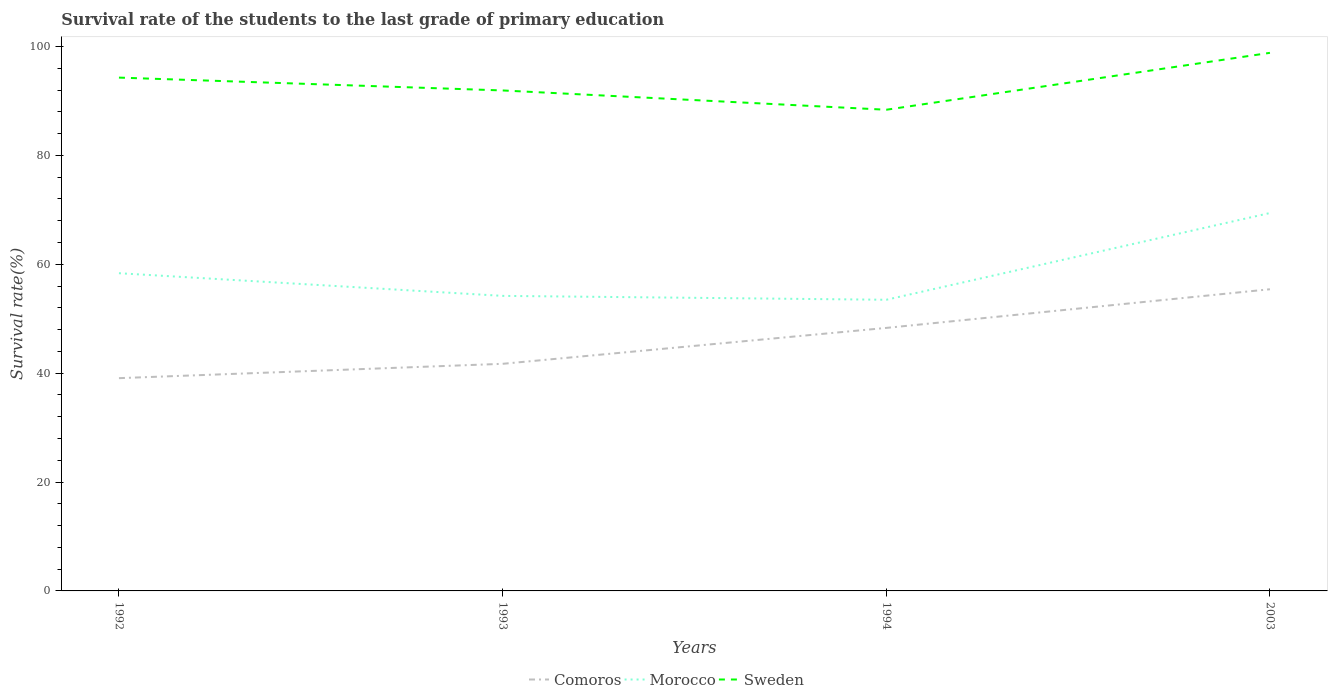How many different coloured lines are there?
Provide a succinct answer. 3. Across all years, what is the maximum survival rate of the students in Comoros?
Make the answer very short. 39.08. In which year was the survival rate of the students in Morocco maximum?
Provide a short and direct response. 1994. What is the total survival rate of the students in Sweden in the graph?
Offer a very short reply. -10.45. What is the difference between the highest and the second highest survival rate of the students in Comoros?
Offer a very short reply. 16.33. What is the difference between the highest and the lowest survival rate of the students in Morocco?
Offer a terse response. 1. How many lines are there?
Offer a terse response. 3. How many years are there in the graph?
Your answer should be compact. 4. Are the values on the major ticks of Y-axis written in scientific E-notation?
Offer a very short reply. No. How many legend labels are there?
Make the answer very short. 3. What is the title of the graph?
Give a very brief answer. Survival rate of the students to the last grade of primary education. Does "Peru" appear as one of the legend labels in the graph?
Ensure brevity in your answer.  No. What is the label or title of the X-axis?
Offer a terse response. Years. What is the label or title of the Y-axis?
Your response must be concise. Survival rate(%). What is the Survival rate(%) of Comoros in 1992?
Provide a short and direct response. 39.08. What is the Survival rate(%) in Morocco in 1992?
Provide a short and direct response. 58.35. What is the Survival rate(%) in Sweden in 1992?
Your answer should be very brief. 94.28. What is the Survival rate(%) in Comoros in 1993?
Your answer should be very brief. 41.71. What is the Survival rate(%) of Morocco in 1993?
Offer a terse response. 54.19. What is the Survival rate(%) of Sweden in 1993?
Your response must be concise. 91.92. What is the Survival rate(%) of Comoros in 1994?
Your answer should be compact. 48.31. What is the Survival rate(%) in Morocco in 1994?
Keep it short and to the point. 53.48. What is the Survival rate(%) of Sweden in 1994?
Your answer should be compact. 88.38. What is the Survival rate(%) of Comoros in 2003?
Offer a very short reply. 55.41. What is the Survival rate(%) of Morocco in 2003?
Make the answer very short. 69.41. What is the Survival rate(%) in Sweden in 2003?
Your answer should be very brief. 98.83. Across all years, what is the maximum Survival rate(%) in Comoros?
Make the answer very short. 55.41. Across all years, what is the maximum Survival rate(%) of Morocco?
Your response must be concise. 69.41. Across all years, what is the maximum Survival rate(%) in Sweden?
Offer a terse response. 98.83. Across all years, what is the minimum Survival rate(%) in Comoros?
Make the answer very short. 39.08. Across all years, what is the minimum Survival rate(%) in Morocco?
Your response must be concise. 53.48. Across all years, what is the minimum Survival rate(%) in Sweden?
Give a very brief answer. 88.38. What is the total Survival rate(%) in Comoros in the graph?
Your answer should be compact. 184.51. What is the total Survival rate(%) in Morocco in the graph?
Ensure brevity in your answer.  235.43. What is the total Survival rate(%) of Sweden in the graph?
Offer a terse response. 373.41. What is the difference between the Survival rate(%) of Comoros in 1992 and that in 1993?
Your response must be concise. -2.64. What is the difference between the Survival rate(%) in Morocco in 1992 and that in 1993?
Ensure brevity in your answer.  4.16. What is the difference between the Survival rate(%) of Sweden in 1992 and that in 1993?
Offer a very short reply. 2.36. What is the difference between the Survival rate(%) of Comoros in 1992 and that in 1994?
Keep it short and to the point. -9.23. What is the difference between the Survival rate(%) of Morocco in 1992 and that in 1994?
Provide a short and direct response. 4.88. What is the difference between the Survival rate(%) in Sweden in 1992 and that in 1994?
Provide a succinct answer. 5.9. What is the difference between the Survival rate(%) in Comoros in 1992 and that in 2003?
Offer a terse response. -16.33. What is the difference between the Survival rate(%) in Morocco in 1992 and that in 2003?
Your answer should be compact. -11.06. What is the difference between the Survival rate(%) of Sweden in 1992 and that in 2003?
Ensure brevity in your answer.  -4.55. What is the difference between the Survival rate(%) of Comoros in 1993 and that in 1994?
Provide a succinct answer. -6.59. What is the difference between the Survival rate(%) of Morocco in 1993 and that in 1994?
Provide a succinct answer. 0.71. What is the difference between the Survival rate(%) of Sweden in 1993 and that in 1994?
Provide a short and direct response. 3.54. What is the difference between the Survival rate(%) in Comoros in 1993 and that in 2003?
Your response must be concise. -13.69. What is the difference between the Survival rate(%) of Morocco in 1993 and that in 2003?
Keep it short and to the point. -15.22. What is the difference between the Survival rate(%) of Sweden in 1993 and that in 2003?
Make the answer very short. -6.91. What is the difference between the Survival rate(%) in Comoros in 1994 and that in 2003?
Offer a very short reply. -7.1. What is the difference between the Survival rate(%) of Morocco in 1994 and that in 2003?
Your answer should be very brief. -15.93. What is the difference between the Survival rate(%) of Sweden in 1994 and that in 2003?
Provide a succinct answer. -10.45. What is the difference between the Survival rate(%) of Comoros in 1992 and the Survival rate(%) of Morocco in 1993?
Your response must be concise. -15.11. What is the difference between the Survival rate(%) in Comoros in 1992 and the Survival rate(%) in Sweden in 1993?
Your answer should be compact. -52.84. What is the difference between the Survival rate(%) of Morocco in 1992 and the Survival rate(%) of Sweden in 1993?
Your response must be concise. -33.57. What is the difference between the Survival rate(%) in Comoros in 1992 and the Survival rate(%) in Morocco in 1994?
Your answer should be compact. -14.4. What is the difference between the Survival rate(%) in Comoros in 1992 and the Survival rate(%) in Sweden in 1994?
Provide a short and direct response. -49.3. What is the difference between the Survival rate(%) in Morocco in 1992 and the Survival rate(%) in Sweden in 1994?
Give a very brief answer. -30.03. What is the difference between the Survival rate(%) of Comoros in 1992 and the Survival rate(%) of Morocco in 2003?
Offer a very short reply. -30.33. What is the difference between the Survival rate(%) of Comoros in 1992 and the Survival rate(%) of Sweden in 2003?
Provide a succinct answer. -59.75. What is the difference between the Survival rate(%) of Morocco in 1992 and the Survival rate(%) of Sweden in 2003?
Make the answer very short. -40.48. What is the difference between the Survival rate(%) in Comoros in 1993 and the Survival rate(%) in Morocco in 1994?
Give a very brief answer. -11.76. What is the difference between the Survival rate(%) in Comoros in 1993 and the Survival rate(%) in Sweden in 1994?
Your response must be concise. -46.67. What is the difference between the Survival rate(%) of Morocco in 1993 and the Survival rate(%) of Sweden in 1994?
Provide a succinct answer. -34.19. What is the difference between the Survival rate(%) of Comoros in 1993 and the Survival rate(%) of Morocco in 2003?
Keep it short and to the point. -27.7. What is the difference between the Survival rate(%) in Comoros in 1993 and the Survival rate(%) in Sweden in 2003?
Offer a terse response. -57.12. What is the difference between the Survival rate(%) of Morocco in 1993 and the Survival rate(%) of Sweden in 2003?
Keep it short and to the point. -44.64. What is the difference between the Survival rate(%) in Comoros in 1994 and the Survival rate(%) in Morocco in 2003?
Ensure brevity in your answer.  -21.1. What is the difference between the Survival rate(%) in Comoros in 1994 and the Survival rate(%) in Sweden in 2003?
Your answer should be very brief. -50.52. What is the difference between the Survival rate(%) in Morocco in 1994 and the Survival rate(%) in Sweden in 2003?
Keep it short and to the point. -45.35. What is the average Survival rate(%) in Comoros per year?
Ensure brevity in your answer.  46.13. What is the average Survival rate(%) in Morocco per year?
Make the answer very short. 58.86. What is the average Survival rate(%) of Sweden per year?
Offer a terse response. 93.35. In the year 1992, what is the difference between the Survival rate(%) of Comoros and Survival rate(%) of Morocco?
Provide a short and direct response. -19.28. In the year 1992, what is the difference between the Survival rate(%) in Comoros and Survival rate(%) in Sweden?
Provide a succinct answer. -55.2. In the year 1992, what is the difference between the Survival rate(%) in Morocco and Survival rate(%) in Sweden?
Offer a terse response. -35.93. In the year 1993, what is the difference between the Survival rate(%) in Comoros and Survival rate(%) in Morocco?
Offer a terse response. -12.48. In the year 1993, what is the difference between the Survival rate(%) of Comoros and Survival rate(%) of Sweden?
Your response must be concise. -50.21. In the year 1993, what is the difference between the Survival rate(%) of Morocco and Survival rate(%) of Sweden?
Your response must be concise. -37.73. In the year 1994, what is the difference between the Survival rate(%) of Comoros and Survival rate(%) of Morocco?
Keep it short and to the point. -5.17. In the year 1994, what is the difference between the Survival rate(%) of Comoros and Survival rate(%) of Sweden?
Offer a very short reply. -40.07. In the year 1994, what is the difference between the Survival rate(%) in Morocco and Survival rate(%) in Sweden?
Keep it short and to the point. -34.9. In the year 2003, what is the difference between the Survival rate(%) of Comoros and Survival rate(%) of Morocco?
Offer a terse response. -14. In the year 2003, what is the difference between the Survival rate(%) in Comoros and Survival rate(%) in Sweden?
Your response must be concise. -43.42. In the year 2003, what is the difference between the Survival rate(%) in Morocco and Survival rate(%) in Sweden?
Your answer should be very brief. -29.42. What is the ratio of the Survival rate(%) in Comoros in 1992 to that in 1993?
Provide a short and direct response. 0.94. What is the ratio of the Survival rate(%) in Morocco in 1992 to that in 1993?
Give a very brief answer. 1.08. What is the ratio of the Survival rate(%) of Sweden in 1992 to that in 1993?
Offer a terse response. 1.03. What is the ratio of the Survival rate(%) of Comoros in 1992 to that in 1994?
Your answer should be very brief. 0.81. What is the ratio of the Survival rate(%) of Morocco in 1992 to that in 1994?
Offer a very short reply. 1.09. What is the ratio of the Survival rate(%) in Sweden in 1992 to that in 1994?
Keep it short and to the point. 1.07. What is the ratio of the Survival rate(%) in Comoros in 1992 to that in 2003?
Your answer should be compact. 0.71. What is the ratio of the Survival rate(%) of Morocco in 1992 to that in 2003?
Your answer should be very brief. 0.84. What is the ratio of the Survival rate(%) of Sweden in 1992 to that in 2003?
Your answer should be very brief. 0.95. What is the ratio of the Survival rate(%) of Comoros in 1993 to that in 1994?
Provide a short and direct response. 0.86. What is the ratio of the Survival rate(%) of Morocco in 1993 to that in 1994?
Offer a terse response. 1.01. What is the ratio of the Survival rate(%) of Sweden in 1993 to that in 1994?
Your answer should be very brief. 1.04. What is the ratio of the Survival rate(%) of Comoros in 1993 to that in 2003?
Your answer should be compact. 0.75. What is the ratio of the Survival rate(%) of Morocco in 1993 to that in 2003?
Ensure brevity in your answer.  0.78. What is the ratio of the Survival rate(%) of Sweden in 1993 to that in 2003?
Give a very brief answer. 0.93. What is the ratio of the Survival rate(%) of Comoros in 1994 to that in 2003?
Offer a terse response. 0.87. What is the ratio of the Survival rate(%) of Morocco in 1994 to that in 2003?
Offer a terse response. 0.77. What is the ratio of the Survival rate(%) of Sweden in 1994 to that in 2003?
Your answer should be compact. 0.89. What is the difference between the highest and the second highest Survival rate(%) in Comoros?
Your answer should be very brief. 7.1. What is the difference between the highest and the second highest Survival rate(%) of Morocco?
Keep it short and to the point. 11.06. What is the difference between the highest and the second highest Survival rate(%) of Sweden?
Make the answer very short. 4.55. What is the difference between the highest and the lowest Survival rate(%) of Comoros?
Provide a succinct answer. 16.33. What is the difference between the highest and the lowest Survival rate(%) in Morocco?
Provide a short and direct response. 15.93. What is the difference between the highest and the lowest Survival rate(%) of Sweden?
Provide a succinct answer. 10.45. 